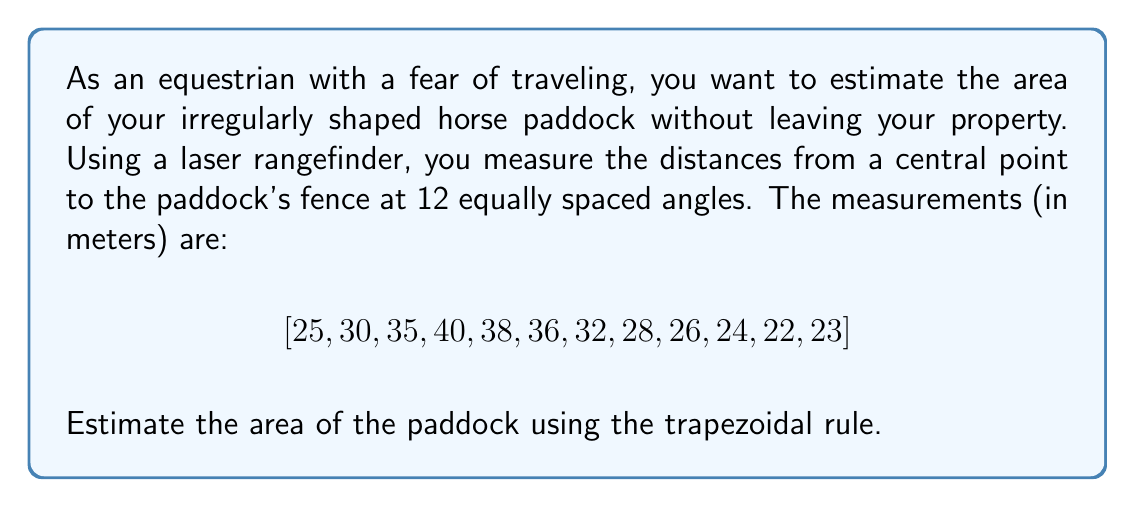Can you solve this math problem? To estimate the area of an irregularly shaped paddock using the trapezoidal rule, we can follow these steps:

1) First, we need to understand that the paddock can be approximated as a polygon with 12 sides.

2) The trapezoidal rule for polar coordinates is given by:

   $$A \approx \frac{1}{2} \sum_{i=1}^{n} (r_i^2 + r_{i+1}^2) \cdot \frac{\pi}{n}$$

   Where $A$ is the area, $r_i$ are the radial measurements, and $n$ is the number of measurements.

3) In our case, $n = 12$, and $\frac{\pi}{n} = \frac{\pi}{12}$.

4) We need to sum $(r_i^2 + r_{i+1}^2)$ for all pairs, including the last and first measurements:

   $$(25^2 + 30^2) + (30^2 + 35^2) + ... + (22^2 + 23^2) + (23^2 + 25^2)$$

5) Let's calculate this sum:
   
   $$1525 + 2125 + 2825 + 3074 + 2920 + 2320 + 1800 + 1460 + 1300 + 1150 + 1013 + 1154 = 22666$$

6) Now we can apply the formula:

   $$A \approx \frac{1}{2} \cdot 22666 \cdot \frac{\pi}{12} \approx 2967.95$$

Therefore, the estimated area of the paddock is approximately 2967.95 square meters.
Answer: The estimated area of the irregularly shaped horse paddock is approximately 2968 m². 